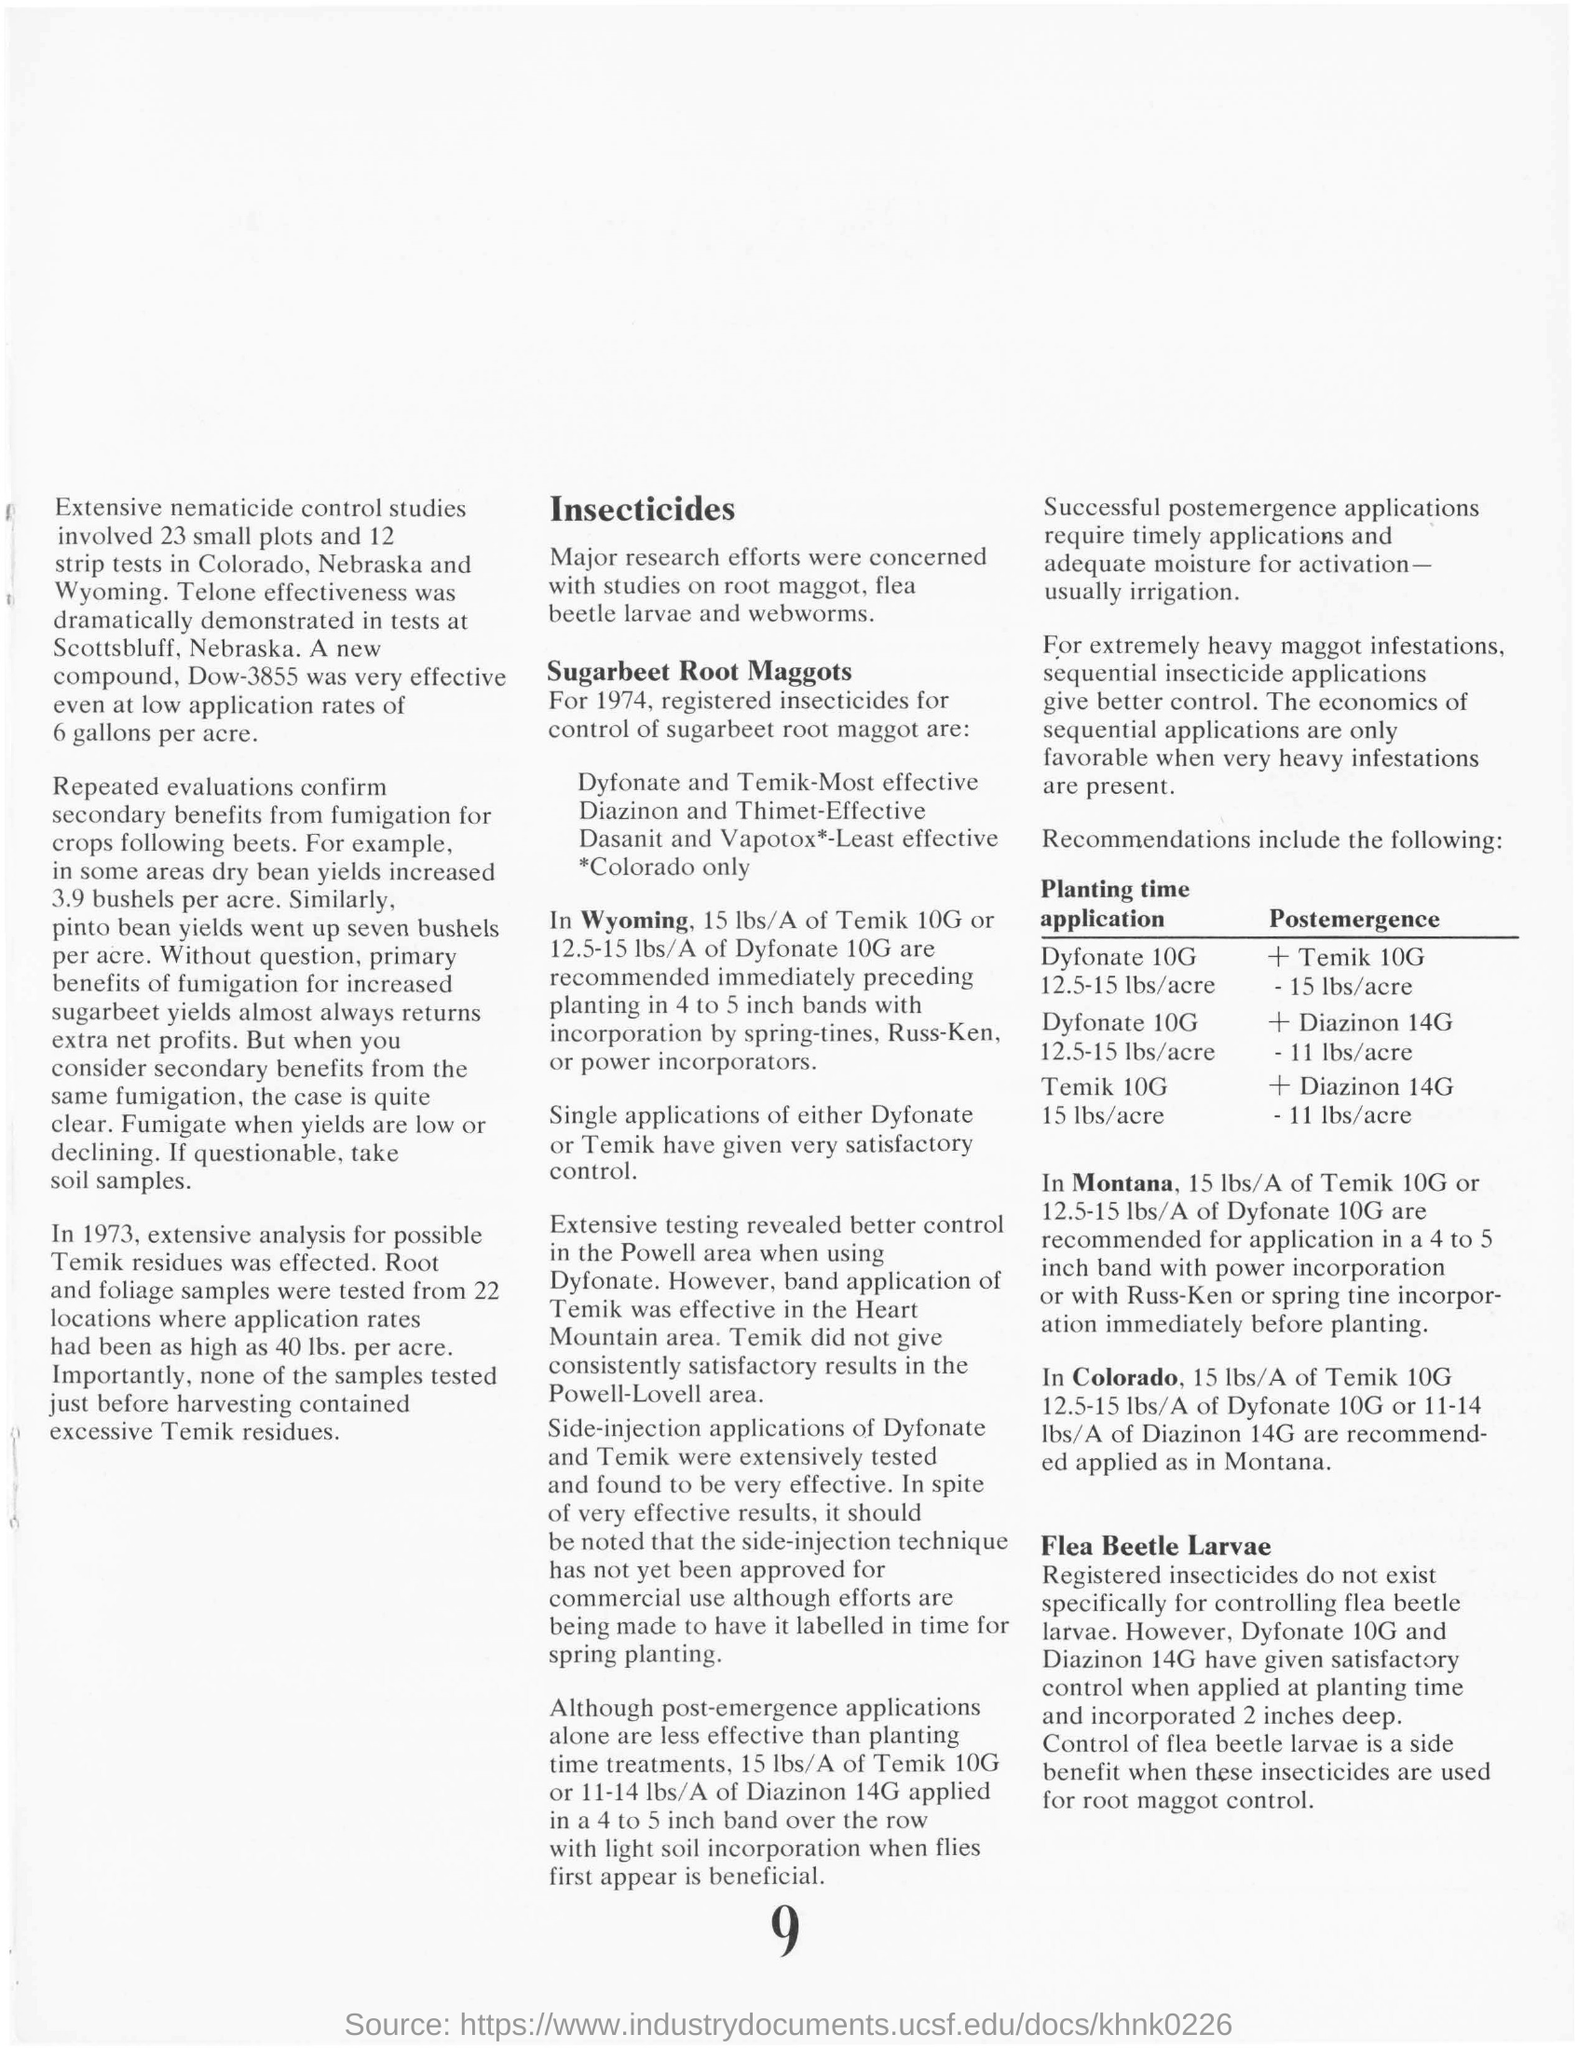Which is the new compound that was very effective even at low application rates?
Your response must be concise. Dow-3855. Which insecticide reveals better control in the Powell area?
Offer a terse response. Dyfonate. What is the title at the top of the second column?
Ensure brevity in your answer.  Insecticides. 